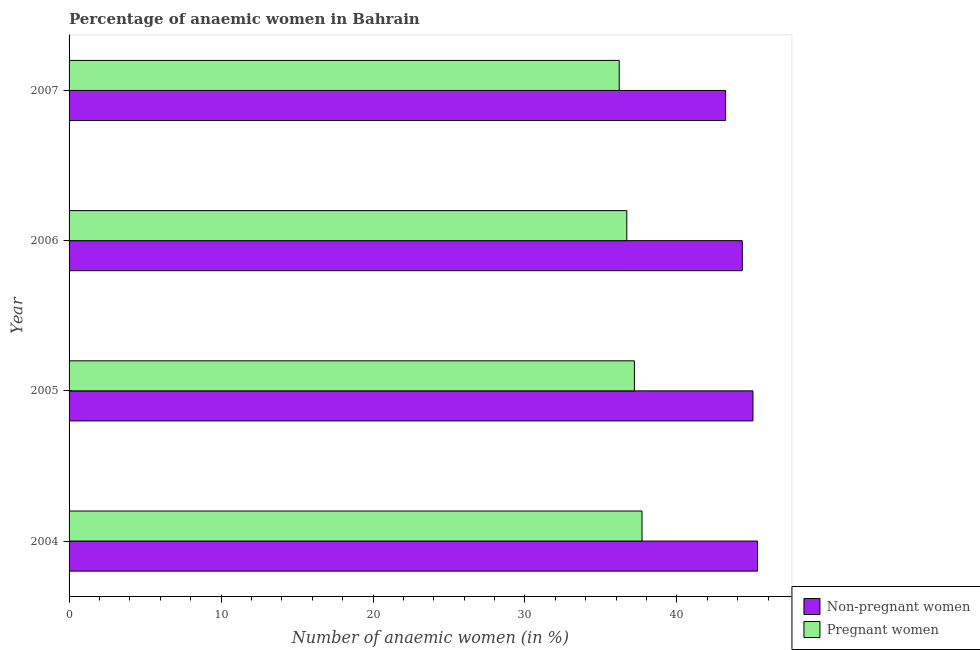How many different coloured bars are there?
Offer a very short reply. 2. What is the label of the 2nd group of bars from the top?
Provide a short and direct response. 2006. In how many cases, is the number of bars for a given year not equal to the number of legend labels?
Provide a succinct answer. 0. Across all years, what is the maximum percentage of pregnant anaemic women?
Offer a very short reply. 37.7. Across all years, what is the minimum percentage of pregnant anaemic women?
Provide a short and direct response. 36.2. In which year was the percentage of pregnant anaemic women maximum?
Provide a succinct answer. 2004. In which year was the percentage of pregnant anaemic women minimum?
Ensure brevity in your answer.  2007. What is the total percentage of non-pregnant anaemic women in the graph?
Keep it short and to the point. 177.8. What is the difference between the percentage of non-pregnant anaemic women in 2005 and the percentage of pregnant anaemic women in 2006?
Your answer should be very brief. 8.3. What is the average percentage of pregnant anaemic women per year?
Give a very brief answer. 36.95. In how many years, is the percentage of pregnant anaemic women greater than 32 %?
Offer a terse response. 4. What is the ratio of the percentage of pregnant anaemic women in 2005 to that in 2007?
Provide a succinct answer. 1.03. Is the percentage of pregnant anaemic women in 2004 less than that in 2006?
Your answer should be compact. No. What is the difference between the highest and the second highest percentage of non-pregnant anaemic women?
Give a very brief answer. 0.3. Is the sum of the percentage of pregnant anaemic women in 2004 and 2005 greater than the maximum percentage of non-pregnant anaemic women across all years?
Offer a very short reply. Yes. What does the 1st bar from the top in 2006 represents?
Offer a terse response. Pregnant women. What does the 2nd bar from the bottom in 2005 represents?
Provide a short and direct response. Pregnant women. How many bars are there?
Provide a succinct answer. 8. What is the difference between two consecutive major ticks on the X-axis?
Offer a terse response. 10. Are the values on the major ticks of X-axis written in scientific E-notation?
Provide a succinct answer. No. What is the title of the graph?
Offer a very short reply. Percentage of anaemic women in Bahrain. What is the label or title of the X-axis?
Provide a succinct answer. Number of anaemic women (in %). What is the label or title of the Y-axis?
Offer a very short reply. Year. What is the Number of anaemic women (in %) in Non-pregnant women in 2004?
Offer a very short reply. 45.3. What is the Number of anaemic women (in %) of Pregnant women in 2004?
Your response must be concise. 37.7. What is the Number of anaemic women (in %) of Pregnant women in 2005?
Keep it short and to the point. 37.2. What is the Number of anaemic women (in %) in Non-pregnant women in 2006?
Your answer should be compact. 44.3. What is the Number of anaemic women (in %) of Pregnant women in 2006?
Make the answer very short. 36.7. What is the Number of anaemic women (in %) of Non-pregnant women in 2007?
Keep it short and to the point. 43.2. What is the Number of anaemic women (in %) in Pregnant women in 2007?
Make the answer very short. 36.2. Across all years, what is the maximum Number of anaemic women (in %) of Non-pregnant women?
Provide a succinct answer. 45.3. Across all years, what is the maximum Number of anaemic women (in %) of Pregnant women?
Provide a succinct answer. 37.7. Across all years, what is the minimum Number of anaemic women (in %) of Non-pregnant women?
Make the answer very short. 43.2. Across all years, what is the minimum Number of anaemic women (in %) of Pregnant women?
Ensure brevity in your answer.  36.2. What is the total Number of anaemic women (in %) in Non-pregnant women in the graph?
Make the answer very short. 177.8. What is the total Number of anaemic women (in %) in Pregnant women in the graph?
Provide a succinct answer. 147.8. What is the difference between the Number of anaemic women (in %) in Non-pregnant women in 2004 and that in 2007?
Make the answer very short. 2.1. What is the difference between the Number of anaemic women (in %) of Non-pregnant women in 2005 and that in 2006?
Give a very brief answer. 0.7. What is the difference between the Number of anaemic women (in %) in Non-pregnant women in 2005 and that in 2007?
Offer a very short reply. 1.8. What is the difference between the Number of anaemic women (in %) of Pregnant women in 2005 and that in 2007?
Provide a succinct answer. 1. What is the difference between the Number of anaemic women (in %) in Non-pregnant women in 2006 and that in 2007?
Your answer should be very brief. 1.1. What is the difference between the Number of anaemic women (in %) of Pregnant women in 2006 and that in 2007?
Make the answer very short. 0.5. What is the difference between the Number of anaemic women (in %) in Non-pregnant women in 2004 and the Number of anaemic women (in %) in Pregnant women in 2006?
Your response must be concise. 8.6. What is the difference between the Number of anaemic women (in %) of Non-pregnant women in 2004 and the Number of anaemic women (in %) of Pregnant women in 2007?
Offer a terse response. 9.1. What is the average Number of anaemic women (in %) in Non-pregnant women per year?
Provide a succinct answer. 44.45. What is the average Number of anaemic women (in %) in Pregnant women per year?
Provide a succinct answer. 36.95. In the year 2004, what is the difference between the Number of anaemic women (in %) of Non-pregnant women and Number of anaemic women (in %) of Pregnant women?
Ensure brevity in your answer.  7.6. What is the ratio of the Number of anaemic women (in %) in Non-pregnant women in 2004 to that in 2005?
Make the answer very short. 1.01. What is the ratio of the Number of anaemic women (in %) of Pregnant women in 2004 to that in 2005?
Make the answer very short. 1.01. What is the ratio of the Number of anaemic women (in %) of Non-pregnant women in 2004 to that in 2006?
Your answer should be very brief. 1.02. What is the ratio of the Number of anaemic women (in %) of Pregnant women in 2004 to that in 2006?
Your answer should be very brief. 1.03. What is the ratio of the Number of anaemic women (in %) in Non-pregnant women in 2004 to that in 2007?
Offer a terse response. 1.05. What is the ratio of the Number of anaemic women (in %) of Pregnant women in 2004 to that in 2007?
Offer a terse response. 1.04. What is the ratio of the Number of anaemic women (in %) in Non-pregnant women in 2005 to that in 2006?
Provide a succinct answer. 1.02. What is the ratio of the Number of anaemic women (in %) in Pregnant women in 2005 to that in 2006?
Your response must be concise. 1.01. What is the ratio of the Number of anaemic women (in %) in Non-pregnant women in 2005 to that in 2007?
Make the answer very short. 1.04. What is the ratio of the Number of anaemic women (in %) of Pregnant women in 2005 to that in 2007?
Offer a terse response. 1.03. What is the ratio of the Number of anaemic women (in %) in Non-pregnant women in 2006 to that in 2007?
Your response must be concise. 1.03. What is the ratio of the Number of anaemic women (in %) of Pregnant women in 2006 to that in 2007?
Your response must be concise. 1.01. What is the difference between the highest and the lowest Number of anaemic women (in %) in Non-pregnant women?
Your answer should be compact. 2.1. 